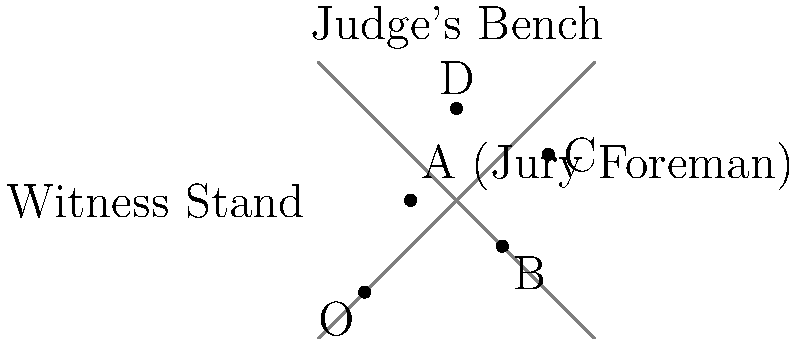In a courtroom scene from a legal drama, the jury members are positioned as shown in the diagram. The judge's bench is at the top, and the witness stand is on the left. If vector $\vec{OA}$ represents the position of the jury foreman relative to the origin O, what is the magnitude of the vector $\vec{AC} - \vec{BD}$? To solve this problem, we need to follow these steps:

1. Identify the coordinates of points A, B, C, and D:
   A(1,2), B(3,1), C(4,3), D(2,4)

2. Calculate vector $\vec{AC}$:
   $\vec{AC} = C - A = (4,3) - (1,2) = (3,1)$

3. Calculate vector $\vec{BD}$:
   $\vec{BD} = D - B = (2,4) - (3,1) = (-1,3)$

4. Calculate $\vec{AC} - \vec{BD}$:
   $\vec{AC} - \vec{BD} = (3,1) - (-1,3) = (3,1) + (1,-3) = (4,-2)$

5. Calculate the magnitude of $\vec{AC} - \vec{BD}$ using the Pythagorean theorem:
   $|\vec{AC} - \vec{BD}| = \sqrt{4^2 + (-2)^2} = \sqrt{16 + 4} = \sqrt{20} = 2\sqrt{5}$

Therefore, the magnitude of vector $\vec{AC} - \vec{BD}$ is $2\sqrt{5}$.
Answer: $2\sqrt{5}$ 